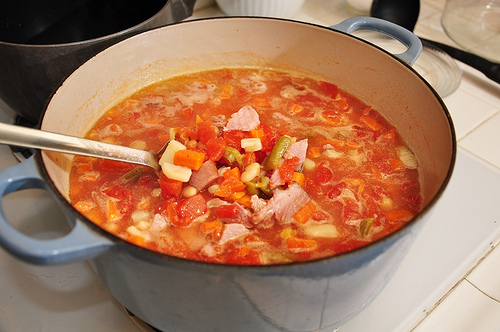<image>
Can you confirm if the soup is in the pot? Yes. The soup is contained within or inside the pot, showing a containment relationship. 